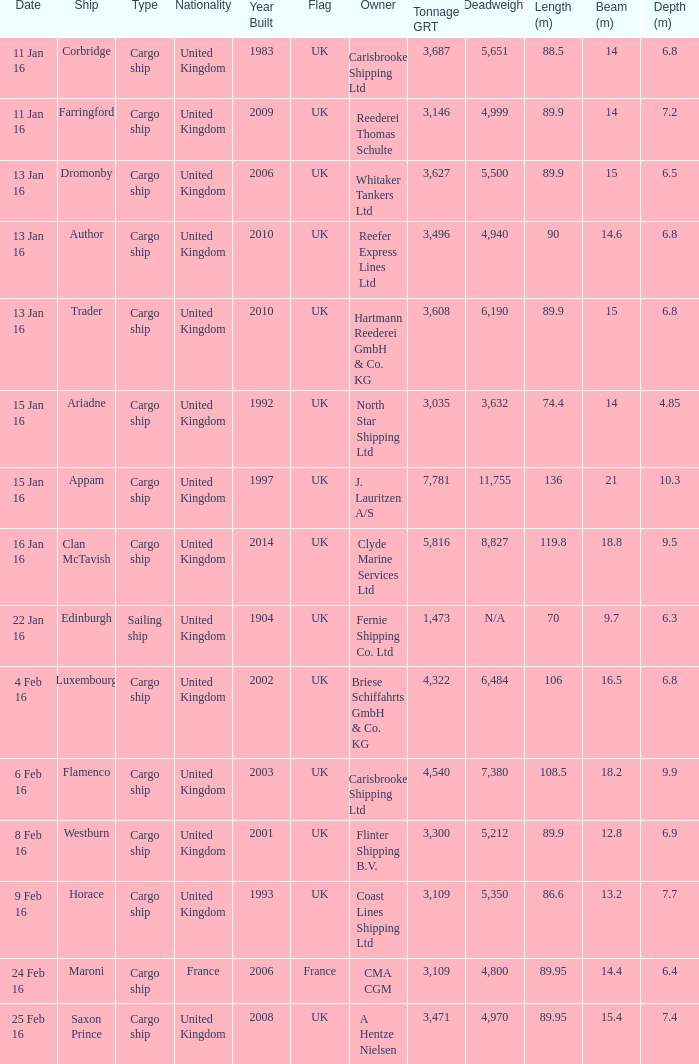What nation does the ship appam belong to? United Kingdom. 